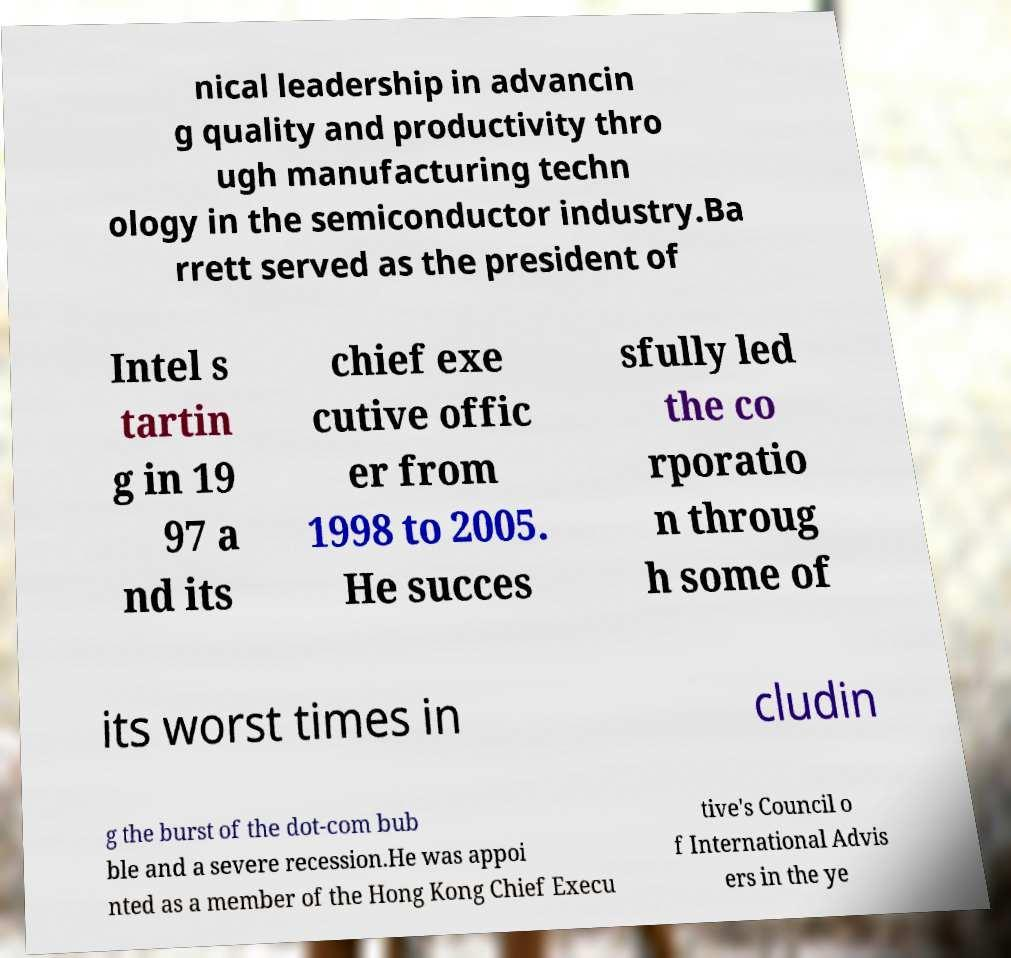Please read and relay the text visible in this image. What does it say? nical leadership in advancin g quality and productivity thro ugh manufacturing techn ology in the semiconductor industry.Ba rrett served as the president of Intel s tartin g in 19 97 a nd its chief exe cutive offic er from 1998 to 2005. He succes sfully led the co rporatio n throug h some of its worst times in cludin g the burst of the dot-com bub ble and a severe recession.He was appoi nted as a member of the Hong Kong Chief Execu tive's Council o f International Advis ers in the ye 